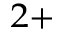<formula> <loc_0><loc_0><loc_500><loc_500>^ { 2 + }</formula> 